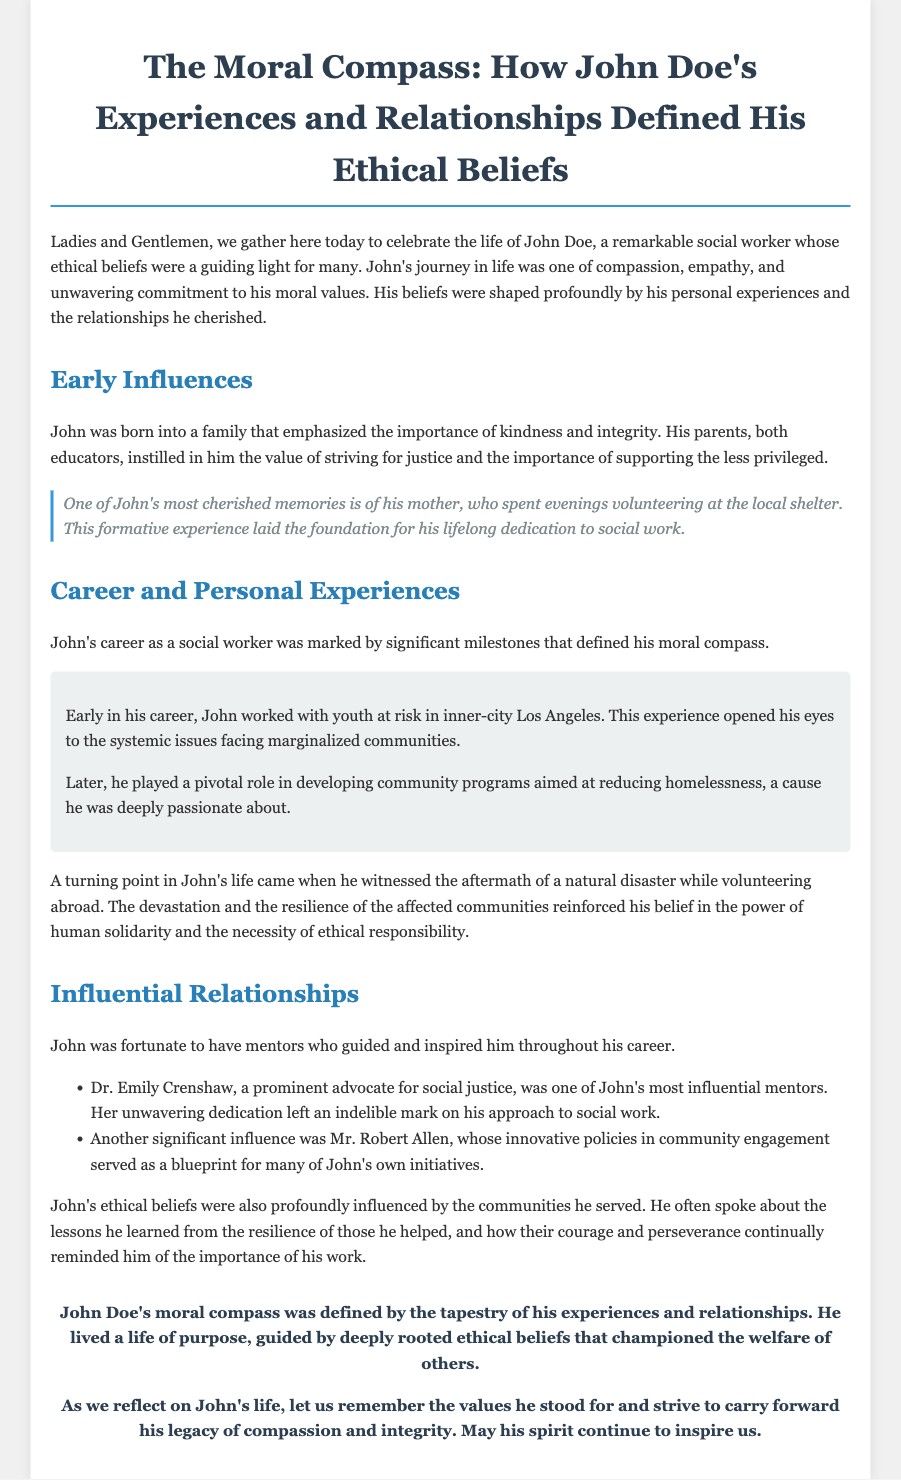What was John Doe's profession? John Doe was described as a remarkable social worker, emphasizing his career in the document.
Answer: social worker Who was one of John's most influential mentors? The document lists Dr. Emily Crenshaw as one of John's mentors who inspired him throughout his career.
Answer: Dr. Emily Crenshaw What community issue was John deeply passionate about? The document highlights that John played a pivotal role in developing community programs aimed at reducing homelessness.
Answer: homelessness What formative experience did John have as a child? The document mentions that John cherished memories of his mother volunteering at the local shelter, which influenced his values.
Answer: volunteering at the local shelter What did John witness that reinforced his belief in human solidarity? John witnessed the aftermath of a natural disaster, which had a significant impact on his ethical beliefs.
Answer: natural disaster How did John's parents influence him? The document states that John's parents, both educators, emphasized the importance of kindness and integrity.
Answer: kindness and integrity What was a major turning point in John's life? A significant event in John's life that shaped his beliefs was witnessing a natural disaster while volunteering abroad.
Answer: witnessing a natural disaster What lesson did John learn from the communities he served? John learned lessons of resilience and courage from the communities he supported, reminding him of the importance of his work.
Answer: resilience and courage What is the main message of John's legacy according to the document? The document calls for remembering the values he stood for, particularly compassion and integrity.
Answer: compassion and integrity 